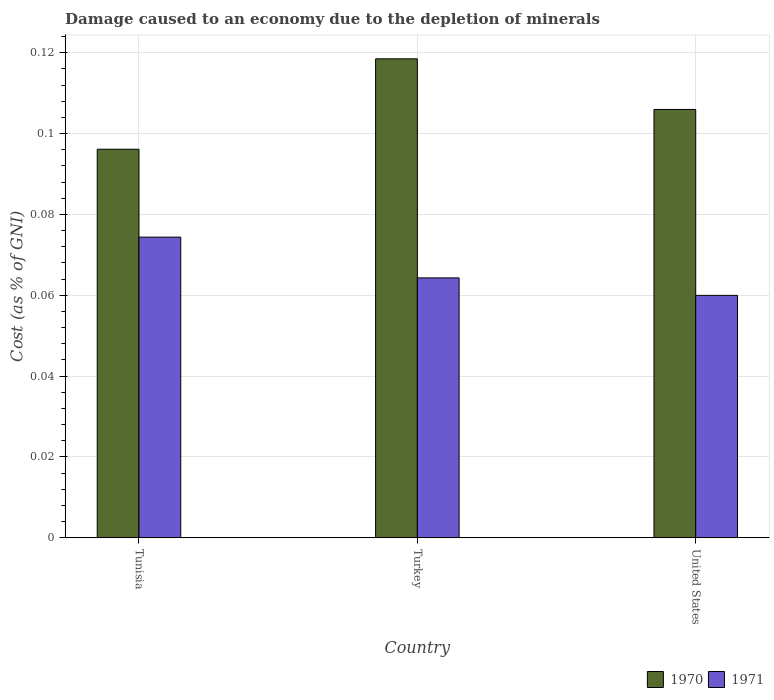How many different coloured bars are there?
Offer a terse response. 2. How many groups of bars are there?
Provide a short and direct response. 3. Are the number of bars on each tick of the X-axis equal?
Keep it short and to the point. Yes. How many bars are there on the 1st tick from the left?
Your answer should be very brief. 2. How many bars are there on the 1st tick from the right?
Your answer should be very brief. 2. What is the label of the 1st group of bars from the left?
Offer a very short reply. Tunisia. What is the cost of damage caused due to the depletion of minerals in 1971 in United States?
Provide a succinct answer. 0.06. Across all countries, what is the maximum cost of damage caused due to the depletion of minerals in 1971?
Your answer should be compact. 0.07. Across all countries, what is the minimum cost of damage caused due to the depletion of minerals in 1970?
Offer a very short reply. 0.1. In which country was the cost of damage caused due to the depletion of minerals in 1971 maximum?
Offer a terse response. Tunisia. What is the total cost of damage caused due to the depletion of minerals in 1970 in the graph?
Give a very brief answer. 0.32. What is the difference between the cost of damage caused due to the depletion of minerals in 1970 in Tunisia and that in United States?
Provide a short and direct response. -0.01. What is the difference between the cost of damage caused due to the depletion of minerals in 1971 in United States and the cost of damage caused due to the depletion of minerals in 1970 in Tunisia?
Make the answer very short. -0.04. What is the average cost of damage caused due to the depletion of minerals in 1970 per country?
Your response must be concise. 0.11. What is the difference between the cost of damage caused due to the depletion of minerals of/in 1971 and cost of damage caused due to the depletion of minerals of/in 1970 in Tunisia?
Your answer should be very brief. -0.02. In how many countries, is the cost of damage caused due to the depletion of minerals in 1970 greater than 0.10400000000000001 %?
Provide a succinct answer. 2. What is the ratio of the cost of damage caused due to the depletion of minerals in 1970 in Tunisia to that in Turkey?
Offer a terse response. 0.81. What is the difference between the highest and the second highest cost of damage caused due to the depletion of minerals in 1971?
Provide a short and direct response. 0.01. What is the difference between the highest and the lowest cost of damage caused due to the depletion of minerals in 1971?
Offer a very short reply. 0.01. In how many countries, is the cost of damage caused due to the depletion of minerals in 1971 greater than the average cost of damage caused due to the depletion of minerals in 1971 taken over all countries?
Give a very brief answer. 1. What does the 1st bar from the left in Tunisia represents?
Offer a terse response. 1970. What does the 2nd bar from the right in Tunisia represents?
Offer a terse response. 1970. Are all the bars in the graph horizontal?
Provide a short and direct response. No. How many countries are there in the graph?
Your answer should be very brief. 3. What is the difference between two consecutive major ticks on the Y-axis?
Provide a succinct answer. 0.02. Where does the legend appear in the graph?
Provide a succinct answer. Bottom right. What is the title of the graph?
Provide a succinct answer. Damage caused to an economy due to the depletion of minerals. Does "1993" appear as one of the legend labels in the graph?
Provide a succinct answer. No. What is the label or title of the X-axis?
Your answer should be compact. Country. What is the label or title of the Y-axis?
Give a very brief answer. Cost (as % of GNI). What is the Cost (as % of GNI) in 1970 in Tunisia?
Give a very brief answer. 0.1. What is the Cost (as % of GNI) in 1971 in Tunisia?
Provide a succinct answer. 0.07. What is the Cost (as % of GNI) of 1970 in Turkey?
Your response must be concise. 0.12. What is the Cost (as % of GNI) in 1971 in Turkey?
Your answer should be compact. 0.06. What is the Cost (as % of GNI) in 1970 in United States?
Give a very brief answer. 0.11. What is the Cost (as % of GNI) of 1971 in United States?
Offer a terse response. 0.06. Across all countries, what is the maximum Cost (as % of GNI) in 1970?
Give a very brief answer. 0.12. Across all countries, what is the maximum Cost (as % of GNI) of 1971?
Offer a very short reply. 0.07. Across all countries, what is the minimum Cost (as % of GNI) in 1970?
Your answer should be very brief. 0.1. Across all countries, what is the minimum Cost (as % of GNI) in 1971?
Give a very brief answer. 0.06. What is the total Cost (as % of GNI) in 1970 in the graph?
Keep it short and to the point. 0.32. What is the total Cost (as % of GNI) of 1971 in the graph?
Ensure brevity in your answer.  0.2. What is the difference between the Cost (as % of GNI) in 1970 in Tunisia and that in Turkey?
Make the answer very short. -0.02. What is the difference between the Cost (as % of GNI) of 1971 in Tunisia and that in Turkey?
Offer a very short reply. 0.01. What is the difference between the Cost (as % of GNI) in 1970 in Tunisia and that in United States?
Make the answer very short. -0.01. What is the difference between the Cost (as % of GNI) in 1971 in Tunisia and that in United States?
Give a very brief answer. 0.01. What is the difference between the Cost (as % of GNI) of 1970 in Turkey and that in United States?
Your response must be concise. 0.01. What is the difference between the Cost (as % of GNI) of 1971 in Turkey and that in United States?
Offer a very short reply. 0. What is the difference between the Cost (as % of GNI) of 1970 in Tunisia and the Cost (as % of GNI) of 1971 in Turkey?
Keep it short and to the point. 0.03. What is the difference between the Cost (as % of GNI) in 1970 in Tunisia and the Cost (as % of GNI) in 1971 in United States?
Provide a short and direct response. 0.04. What is the difference between the Cost (as % of GNI) of 1970 in Turkey and the Cost (as % of GNI) of 1971 in United States?
Provide a short and direct response. 0.06. What is the average Cost (as % of GNI) in 1970 per country?
Provide a succinct answer. 0.11. What is the average Cost (as % of GNI) of 1971 per country?
Offer a terse response. 0.07. What is the difference between the Cost (as % of GNI) of 1970 and Cost (as % of GNI) of 1971 in Tunisia?
Give a very brief answer. 0.02. What is the difference between the Cost (as % of GNI) of 1970 and Cost (as % of GNI) of 1971 in Turkey?
Your response must be concise. 0.05. What is the difference between the Cost (as % of GNI) of 1970 and Cost (as % of GNI) of 1971 in United States?
Make the answer very short. 0.05. What is the ratio of the Cost (as % of GNI) of 1970 in Tunisia to that in Turkey?
Offer a terse response. 0.81. What is the ratio of the Cost (as % of GNI) in 1971 in Tunisia to that in Turkey?
Keep it short and to the point. 1.16. What is the ratio of the Cost (as % of GNI) in 1970 in Tunisia to that in United States?
Provide a short and direct response. 0.91. What is the ratio of the Cost (as % of GNI) of 1971 in Tunisia to that in United States?
Offer a terse response. 1.24. What is the ratio of the Cost (as % of GNI) in 1970 in Turkey to that in United States?
Provide a short and direct response. 1.12. What is the ratio of the Cost (as % of GNI) of 1971 in Turkey to that in United States?
Make the answer very short. 1.07. What is the difference between the highest and the second highest Cost (as % of GNI) in 1970?
Offer a very short reply. 0.01. What is the difference between the highest and the second highest Cost (as % of GNI) of 1971?
Your response must be concise. 0.01. What is the difference between the highest and the lowest Cost (as % of GNI) in 1970?
Make the answer very short. 0.02. What is the difference between the highest and the lowest Cost (as % of GNI) of 1971?
Provide a short and direct response. 0.01. 